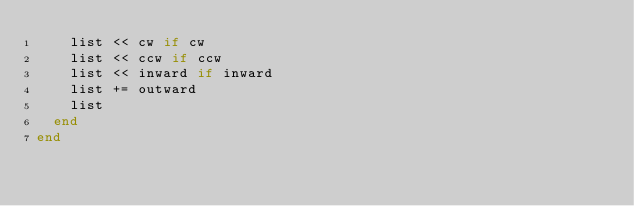Convert code to text. <code><loc_0><loc_0><loc_500><loc_500><_Ruby_>    list << cw if cw
    list << ccw if ccw
    list << inward if inward
    list += outward
    list
  end
end
</code> 